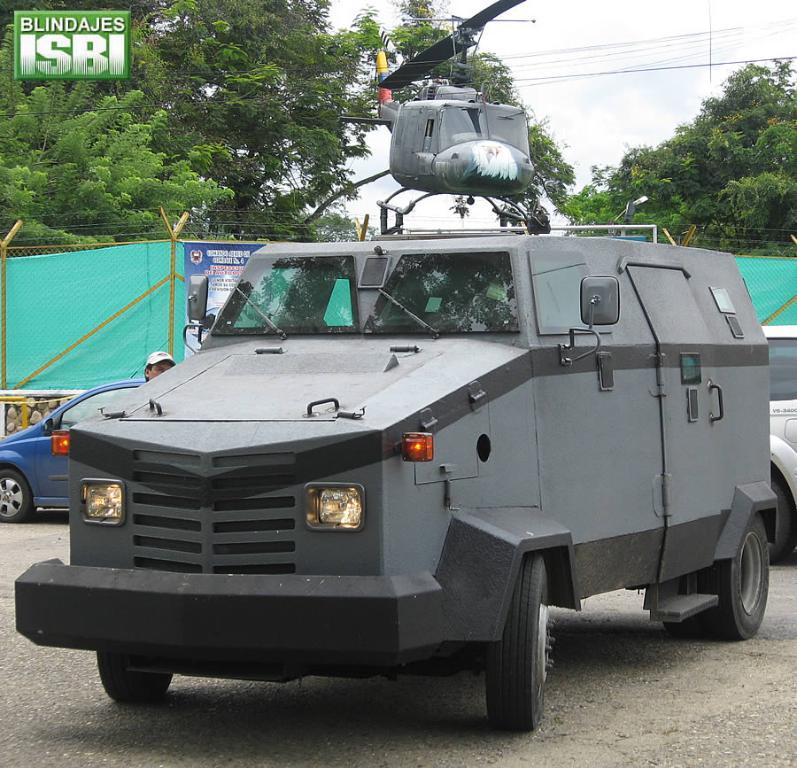What can be seen on the road in the image? There are vehicles on the road in the image. What type of barrier is present in the image? There is a fence in the image. What type of aircraft is visible in the image? A helicopter is visible in the image. What type of vegetation is present in the image? Trees are present in the image. What is located in the top left corner of the image? There is a logo in the top left corner of the image. How many balls are being juggled by the helicopter in the image? There are no balls present in the image, and the helicopter is not shown juggling anything. 